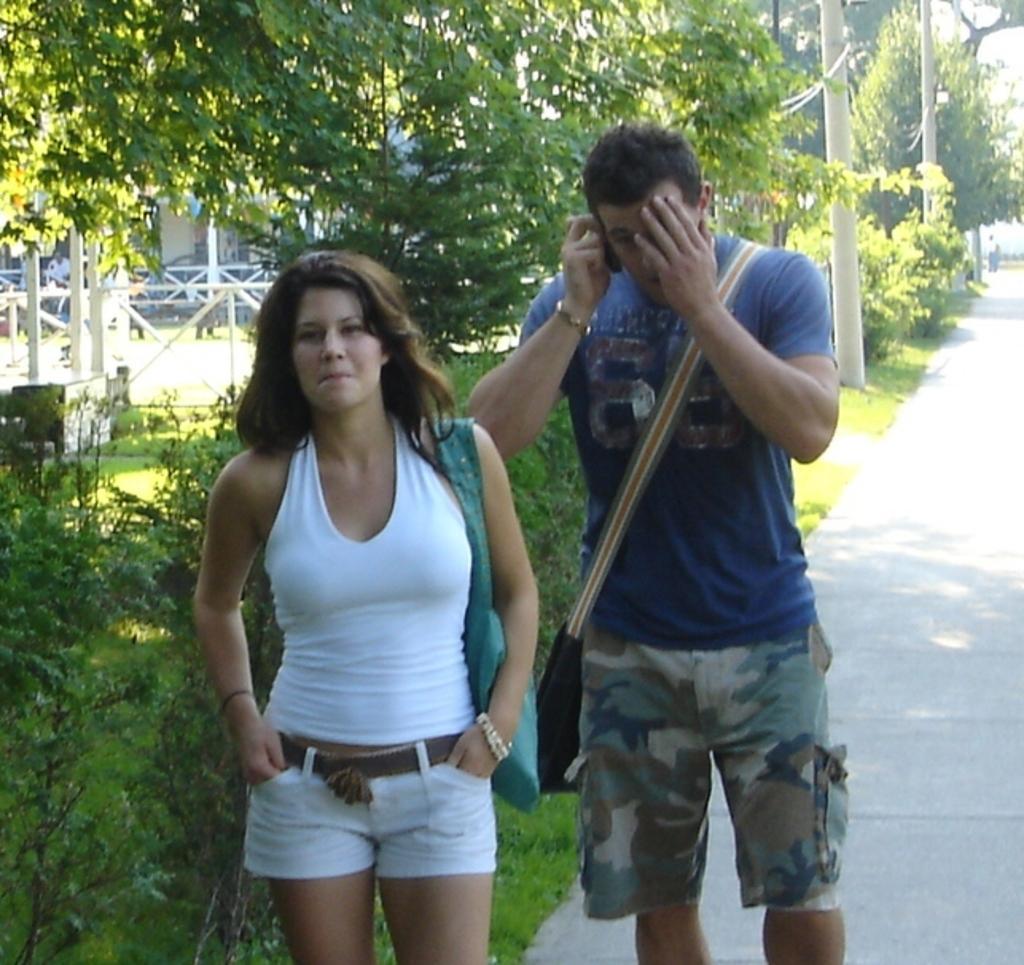Describe this image in one or two sentences. There is a man, it seems like talking on the phone and a woman standing in the foreground area of the image, there are trees, it seems like a house and poles in the background. 